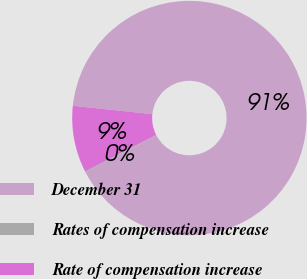Convert chart to OTSL. <chart><loc_0><loc_0><loc_500><loc_500><pie_chart><fcel>December 31<fcel>Rates of compensation increase<fcel>Rate of compensation increase<nl><fcel>90.65%<fcel>0.15%<fcel>9.2%<nl></chart> 